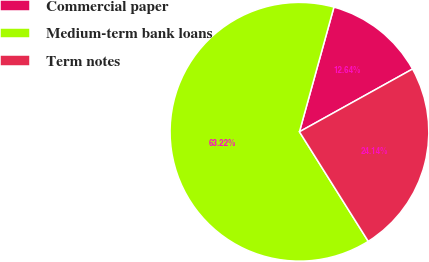Convert chart. <chart><loc_0><loc_0><loc_500><loc_500><pie_chart><fcel>Commercial paper<fcel>Medium-term bank loans<fcel>Term notes<nl><fcel>12.64%<fcel>63.22%<fcel>24.14%<nl></chart> 